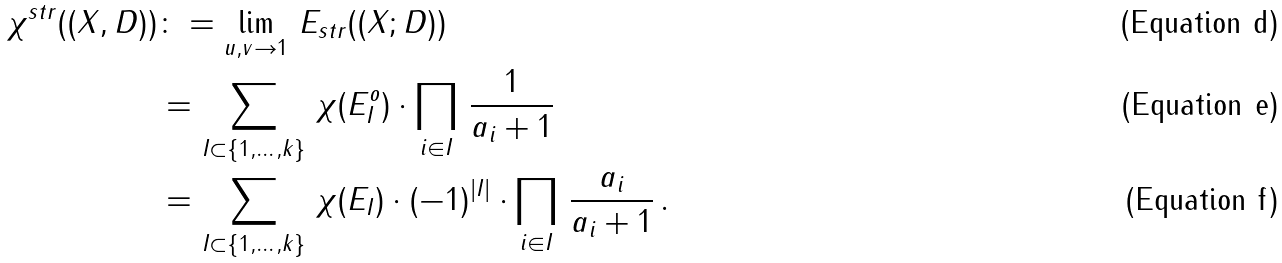Convert formula to latex. <formula><loc_0><loc_0><loc_500><loc_500>\chi ^ { s t r } ( ( X , D ) ) & \colon = \lim _ { u , v \to 1 } \, E _ { s t r } ( ( X ; D ) ) \\ & = \sum _ { I \subset \{ 1 , \dots , k \} } \, \chi ( E _ { I } ^ { o } ) \cdot \prod _ { i \in I } \, \frac { 1 } { a _ { i } + 1 } \\ & = \sum _ { I \subset \{ 1 , \dots , k \} } \, \chi ( E _ { I } ) \cdot ( - 1 ) ^ { | I | } \cdot \prod _ { i \in I } \, \frac { a _ { i } } { a _ { i } + 1 } \, .</formula> 